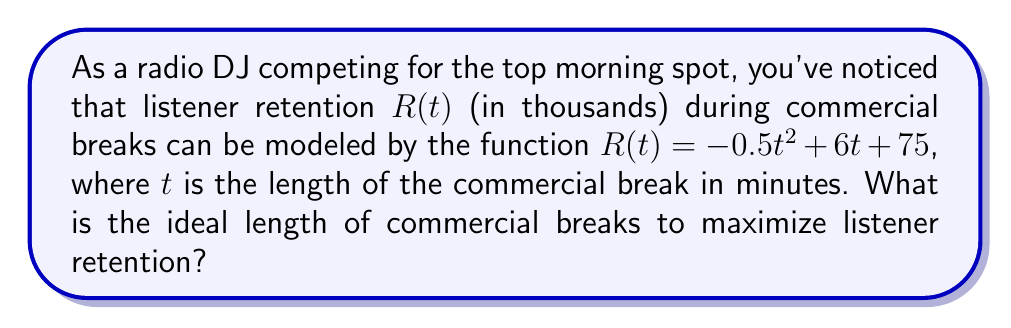Show me your answer to this math problem. To find the ideal length of commercial breaks that maximizes listener retention, we need to find the maximum point of the given function. This can be done using calculus:

1) First, let's find the derivative of $R(t)$:
   $$R'(t) = -t + 6$$

2) To find the maximum point, we set the derivative equal to zero and solve for $t$:
   $$-t + 6 = 0$$
   $$-t = -6$$
   $$t = 6$$

3) To confirm this is a maximum (not a minimum), we can check the second derivative:
   $$R''(t) = -1$$
   Since $R''(t)$ is negative, we confirm that $t = 6$ gives a maximum.

4) Therefore, the ideal length of commercial breaks is 6 minutes.

5) We can calculate the maximum listener retention by plugging $t = 6$ into the original function:
   $$R(6) = -0.5(6)^2 + 6(6) + 75 = -18 + 36 + 75 = 93$$

Thus, the maximum listener retention is 93,000 listeners.
Answer: 6 minutes 